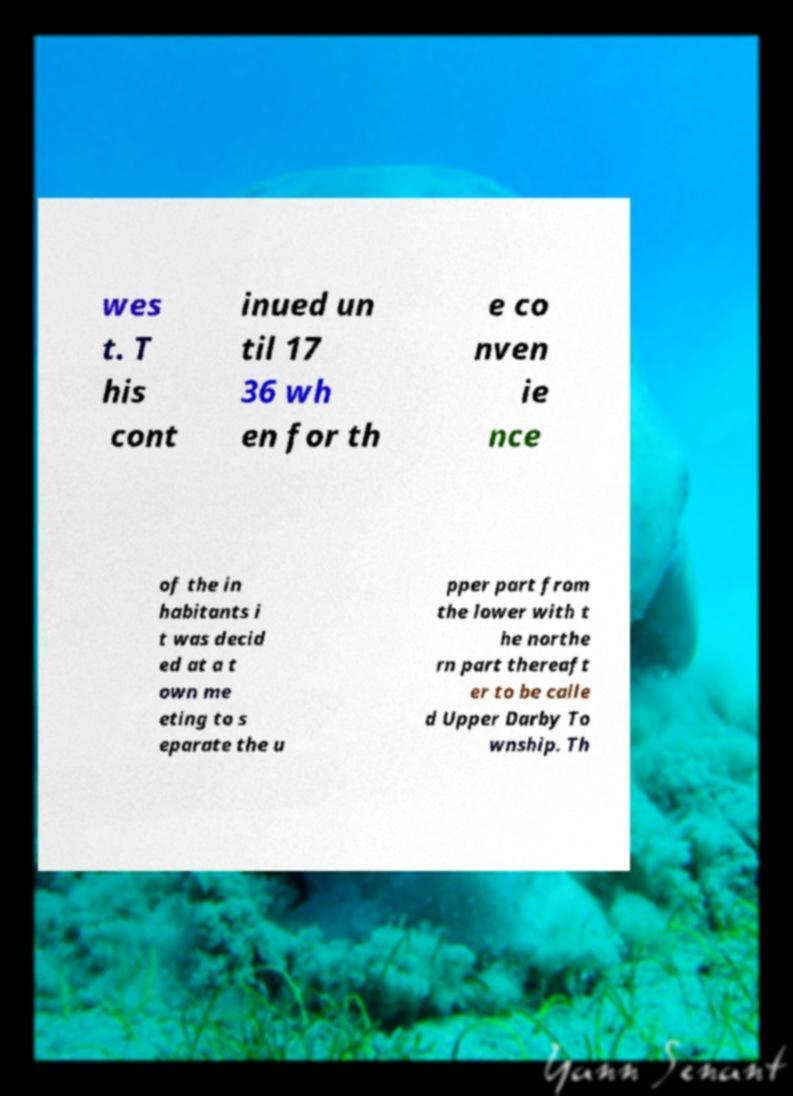Please identify and transcribe the text found in this image. wes t. T his cont inued un til 17 36 wh en for th e co nven ie nce of the in habitants i t was decid ed at a t own me eting to s eparate the u pper part from the lower with t he northe rn part thereaft er to be calle d Upper Darby To wnship. Th 